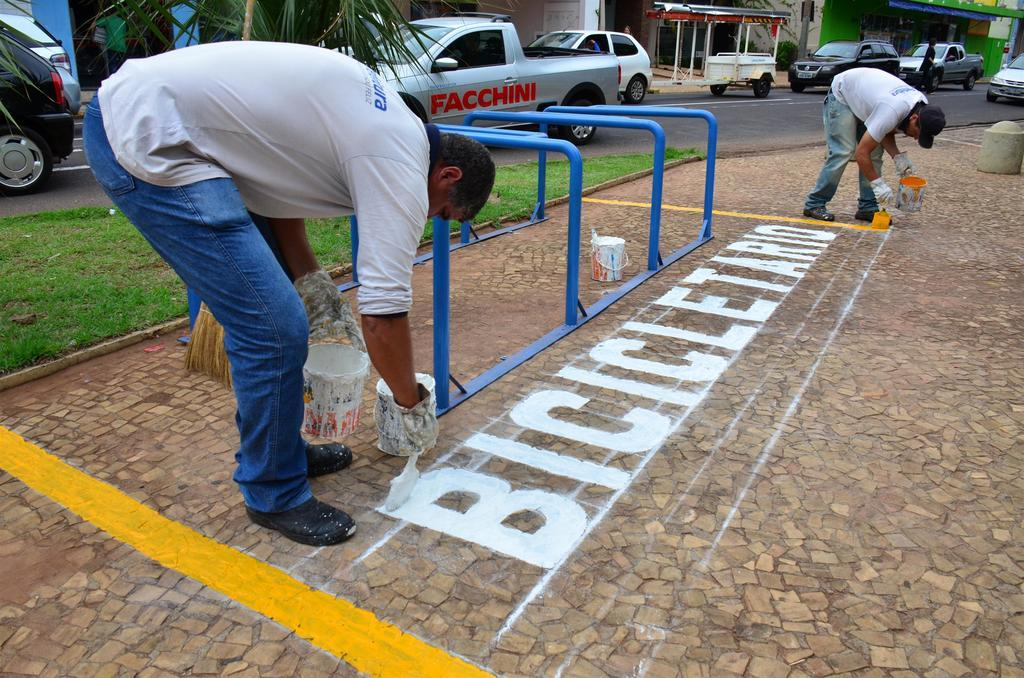What is the main setting of the image? The image is of a street. What can be seen on the road in the image? There are vehicles on the road in the image. What are the people holding in the image? The people are holding paint brushes. What is beside one of the people with a paint brush? There is a paint bucket beside one of the people. What type of establishments can be seen in the image? There are stores visible in the image. What is the color of the grass in the image? The grass is green in color. What shape is the father's hat in the image? There is no father or hat present in the image. 